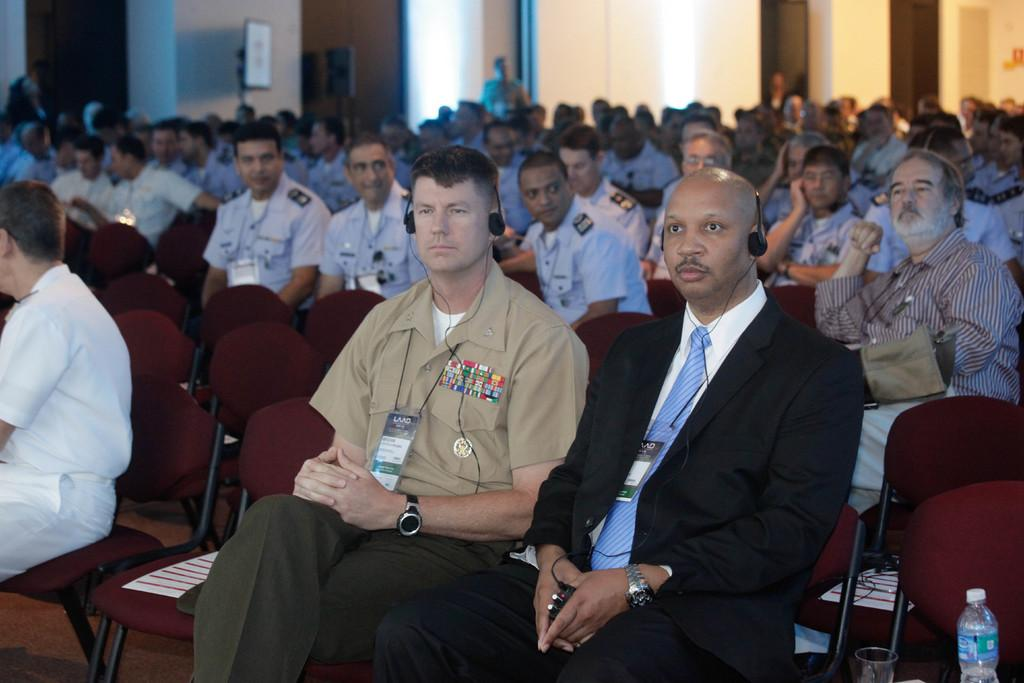What are the people in the foreground of the image doing? The people in the foreground of the image are sitting on chairs. What can be seen in the background of the image? There is a wall and doors in the background of the image. What type of beam is holding up the ceiling in the image? There is no beam visible in the image, and the ceiling is not mentioned in the provided facts. 